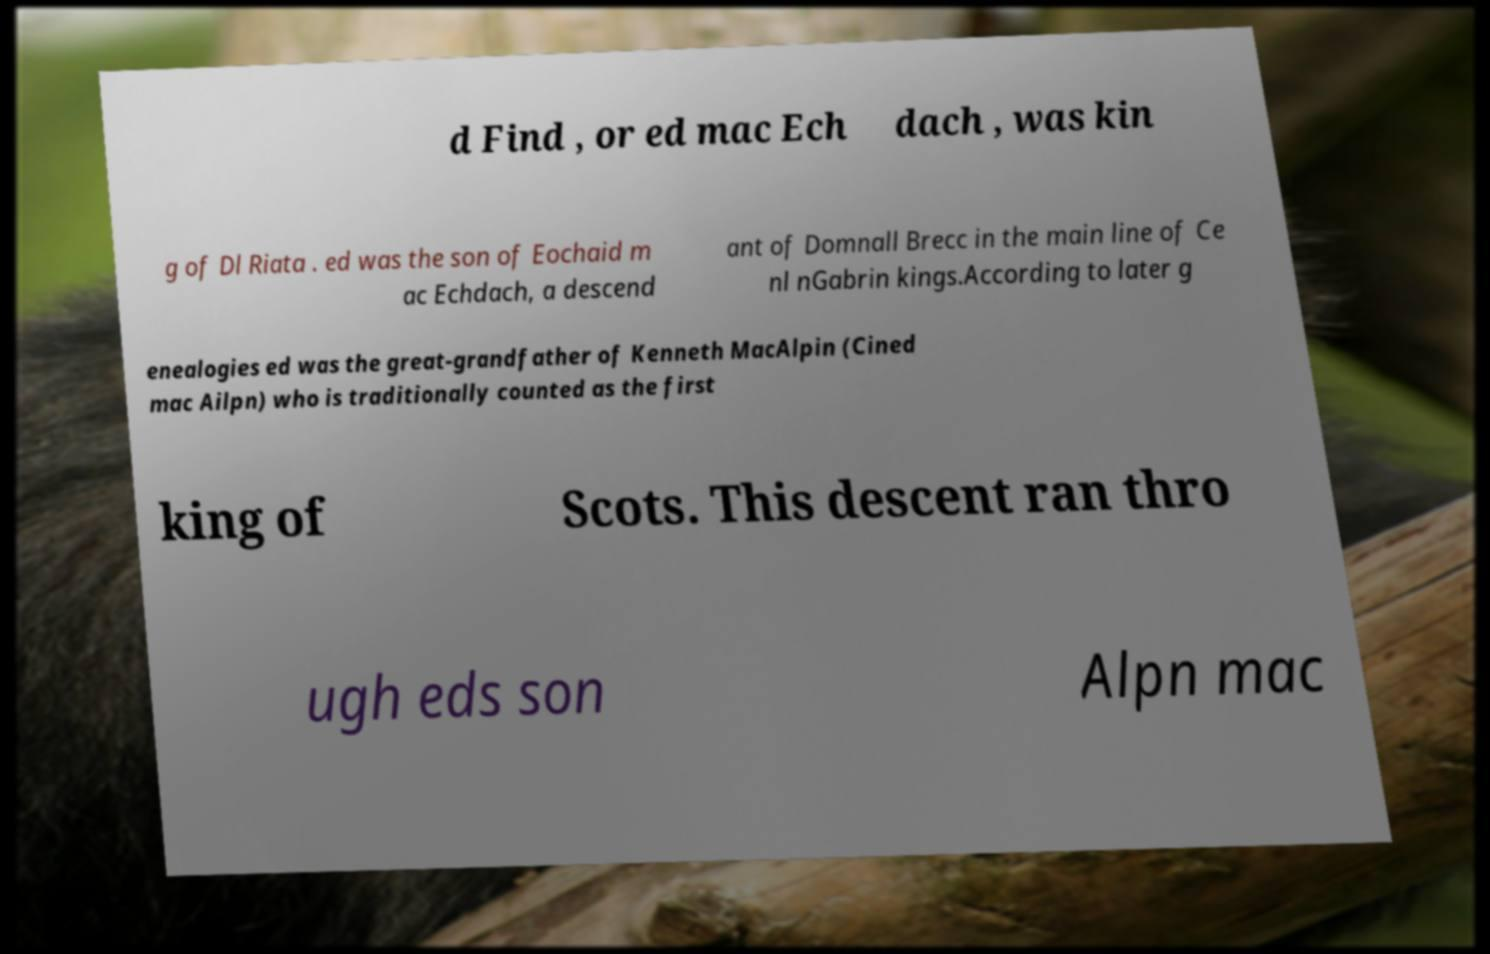Can you read and provide the text displayed in the image?This photo seems to have some interesting text. Can you extract and type it out for me? d Find , or ed mac Ech dach , was kin g of Dl Riata . ed was the son of Eochaid m ac Echdach, a descend ant of Domnall Brecc in the main line of Ce nl nGabrin kings.According to later g enealogies ed was the great-grandfather of Kenneth MacAlpin (Cined mac Ailpn) who is traditionally counted as the first king of Scots. This descent ran thro ugh eds son Alpn mac 